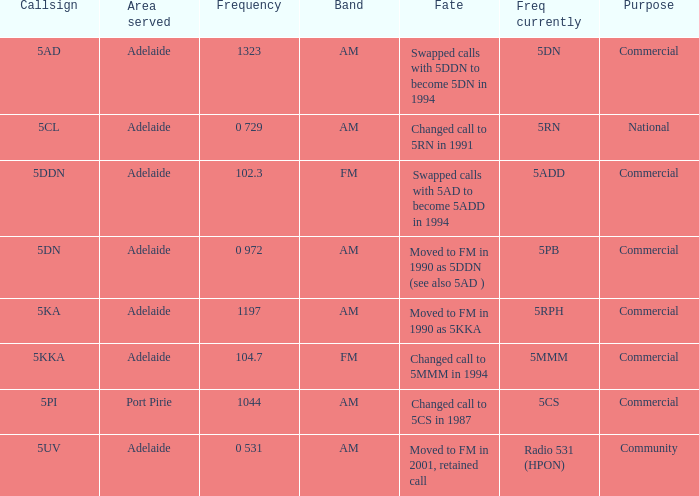What is the current freq for Frequency of 104.7? 5MMM. 